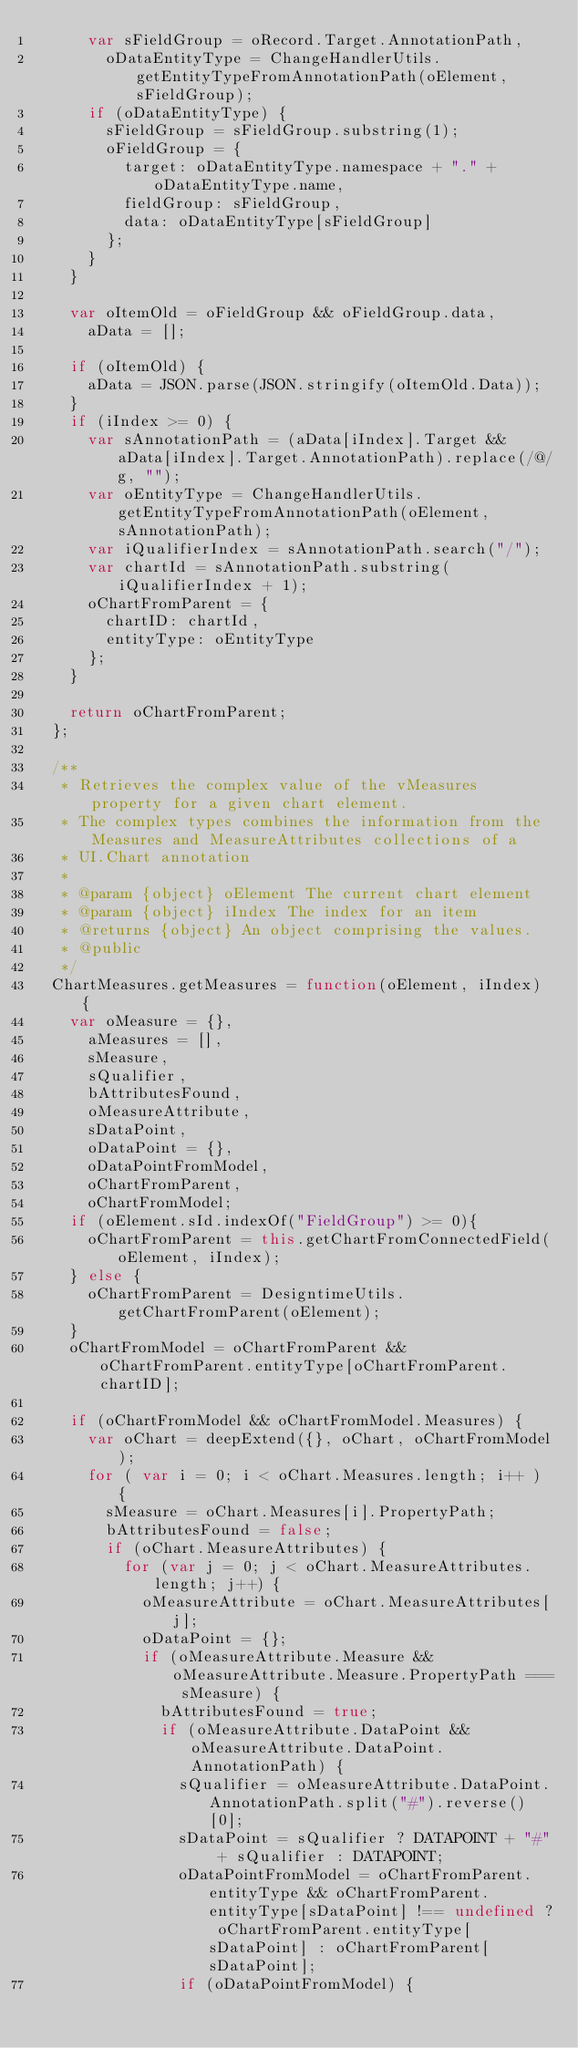Convert code to text. <code><loc_0><loc_0><loc_500><loc_500><_JavaScript_>			var sFieldGroup = oRecord.Target.AnnotationPath,
				oDataEntityType = ChangeHandlerUtils.getEntityTypeFromAnnotationPath(oElement, sFieldGroup);
			if (oDataEntityType) {
				sFieldGroup = sFieldGroup.substring(1);
				oFieldGroup = {
					target: oDataEntityType.namespace + "." + oDataEntityType.name,
					fieldGroup: sFieldGroup,
					data: oDataEntityType[sFieldGroup]
				};
			}
		}

		var oItemOld = oFieldGroup && oFieldGroup.data,
			aData = [];

		if (oItemOld) {
			aData = JSON.parse(JSON.stringify(oItemOld.Data));
		}
		if (iIndex >= 0) {
			var sAnnotationPath = (aData[iIndex].Target && aData[iIndex].Target.AnnotationPath).replace(/@/g, "");
			var oEntityType = ChangeHandlerUtils.getEntityTypeFromAnnotationPath(oElement, sAnnotationPath);
			var iQualifierIndex = sAnnotationPath.search("/");
			var chartId = sAnnotationPath.substring(iQualifierIndex + 1);
			oChartFromParent = {
				chartID: chartId,
				entityType: oEntityType
			};
		}

		return oChartFromParent;
	};

	/**
	 * Retrieves the complex value of the vMeasures property for a given chart element.
	 * The complex types combines the information from the Measures and MeasureAttributes collections of a
	 * UI.Chart annotation
	 *
	 * @param {object} oElement The current chart element
	 * @param {object} iIndex The index for an item
	 * @returns {object} An object comprising the values.
	 * @public
	 */
	ChartMeasures.getMeasures = function(oElement, iIndex) {
		var oMeasure = {},
			aMeasures = [],
			sMeasure,
			sQualifier,
			bAttributesFound,
			oMeasureAttribute,
			sDataPoint,
			oDataPoint = {},
			oDataPointFromModel,
			oChartFromParent,
			oChartFromModel;
		if (oElement.sId.indexOf("FieldGroup") >= 0){
			oChartFromParent = this.getChartFromConnectedField(oElement, iIndex);
		} else {
			oChartFromParent = DesigntimeUtils.getChartFromParent(oElement);
		}
		oChartFromModel = oChartFromParent && oChartFromParent.entityType[oChartFromParent.chartID];

		if (oChartFromModel && oChartFromModel.Measures) {
			var oChart = deepExtend({}, oChart, oChartFromModel);
			for ( var i = 0; i < oChart.Measures.length; i++ ) {
				sMeasure = oChart.Measures[i].PropertyPath;
				bAttributesFound = false;
				if (oChart.MeasureAttributes) {
					for (var j = 0; j < oChart.MeasureAttributes.length; j++) {
						oMeasureAttribute = oChart.MeasureAttributes[j];
						oDataPoint = {};
						if (oMeasureAttribute.Measure && oMeasureAttribute.Measure.PropertyPath === sMeasure) {
							bAttributesFound = true;
							if (oMeasureAttribute.DataPoint && oMeasureAttribute.DataPoint.AnnotationPath) {
								sQualifier = oMeasureAttribute.DataPoint.AnnotationPath.split("#").reverse()[0];
								sDataPoint = sQualifier ? DATAPOINT + "#" + sQualifier : DATAPOINT;
								oDataPointFromModel = oChartFromParent.entityType && oChartFromParent.entityType[sDataPoint] !== undefined ? oChartFromParent.entityType[sDataPoint] : oChartFromParent[sDataPoint];
								if (oDataPointFromModel) {</code> 